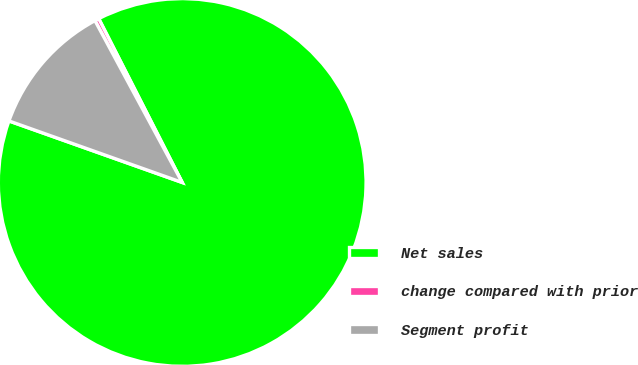Convert chart. <chart><loc_0><loc_0><loc_500><loc_500><pie_chart><fcel>Net sales<fcel>change compared with prior<fcel>Segment profit<nl><fcel>87.94%<fcel>0.37%<fcel>11.7%<nl></chart> 